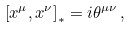<formula> <loc_0><loc_0><loc_500><loc_500>\left [ x ^ { \mu } , x ^ { \nu } \right ] _ { \ast } = i \theta ^ { \mu \nu } \, ,</formula> 